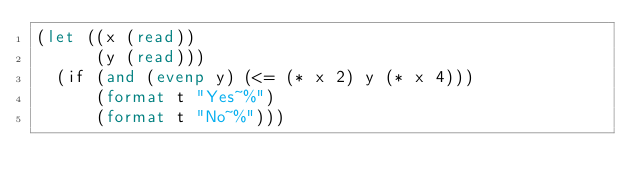<code> <loc_0><loc_0><loc_500><loc_500><_Lisp_>(let ((x (read))
      (y (read)))
  (if (and (evenp y) (<= (* x 2) y (* x 4)))
      (format t "Yes~%")
      (format t "No~%")))
</code> 